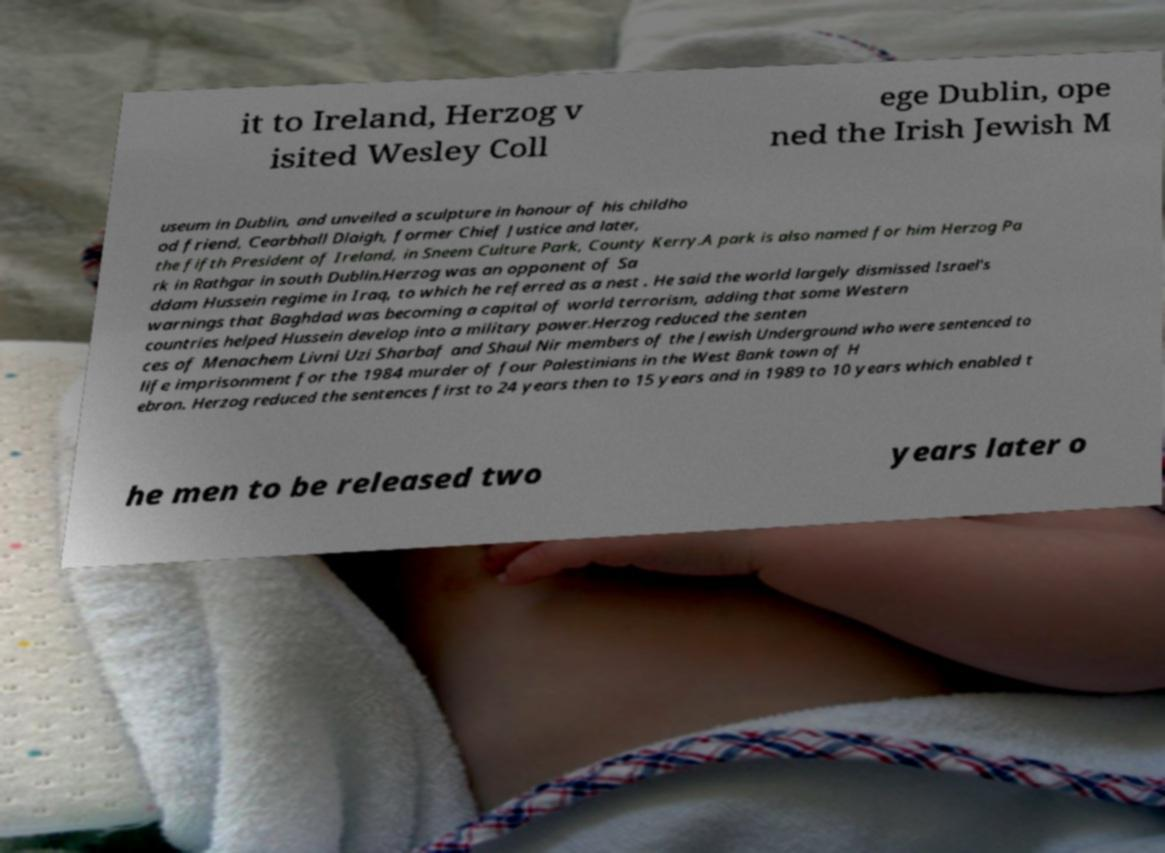What messages or text are displayed in this image? I need them in a readable, typed format. it to Ireland, Herzog v isited Wesley Coll ege Dublin, ope ned the Irish Jewish M useum in Dublin, and unveiled a sculpture in honour of his childho od friend, Cearbhall Dlaigh, former Chief Justice and later, the fifth President of Ireland, in Sneem Culture Park, County Kerry.A park is also named for him Herzog Pa rk in Rathgar in south Dublin.Herzog was an opponent of Sa ddam Hussein regime in Iraq, to which he referred as a nest . He said the world largely dismissed Israel's warnings that Baghdad was becoming a capital of world terrorism, adding that some Western countries helped Hussein develop into a military power.Herzog reduced the senten ces of Menachem Livni Uzi Sharbaf and Shaul Nir members of the Jewish Underground who were sentenced to life imprisonment for the 1984 murder of four Palestinians in the West Bank town of H ebron. Herzog reduced the sentences first to 24 years then to 15 years and in 1989 to 10 years which enabled t he men to be released two years later o 